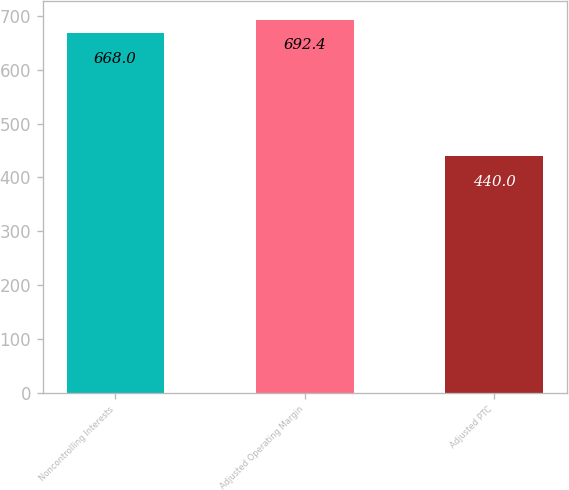<chart> <loc_0><loc_0><loc_500><loc_500><bar_chart><fcel>Noncontrolling Interests<fcel>Adjusted Operating Margin<fcel>Adjusted PTC<nl><fcel>668<fcel>692.4<fcel>440<nl></chart> 